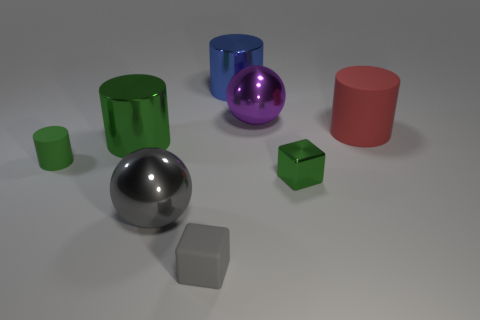Subtract all yellow spheres. How many green cylinders are left? 2 Subtract all big cylinders. How many cylinders are left? 1 Subtract all red cylinders. How many cylinders are left? 3 Subtract all gray cylinders. Subtract all gray spheres. How many cylinders are left? 4 Add 2 small gray matte blocks. How many objects exist? 10 Subtract all spheres. How many objects are left? 6 Add 7 small cylinders. How many small cylinders are left? 8 Add 3 purple objects. How many purple objects exist? 4 Subtract 0 green balls. How many objects are left? 8 Subtract all small purple cylinders. Subtract all tiny cylinders. How many objects are left? 7 